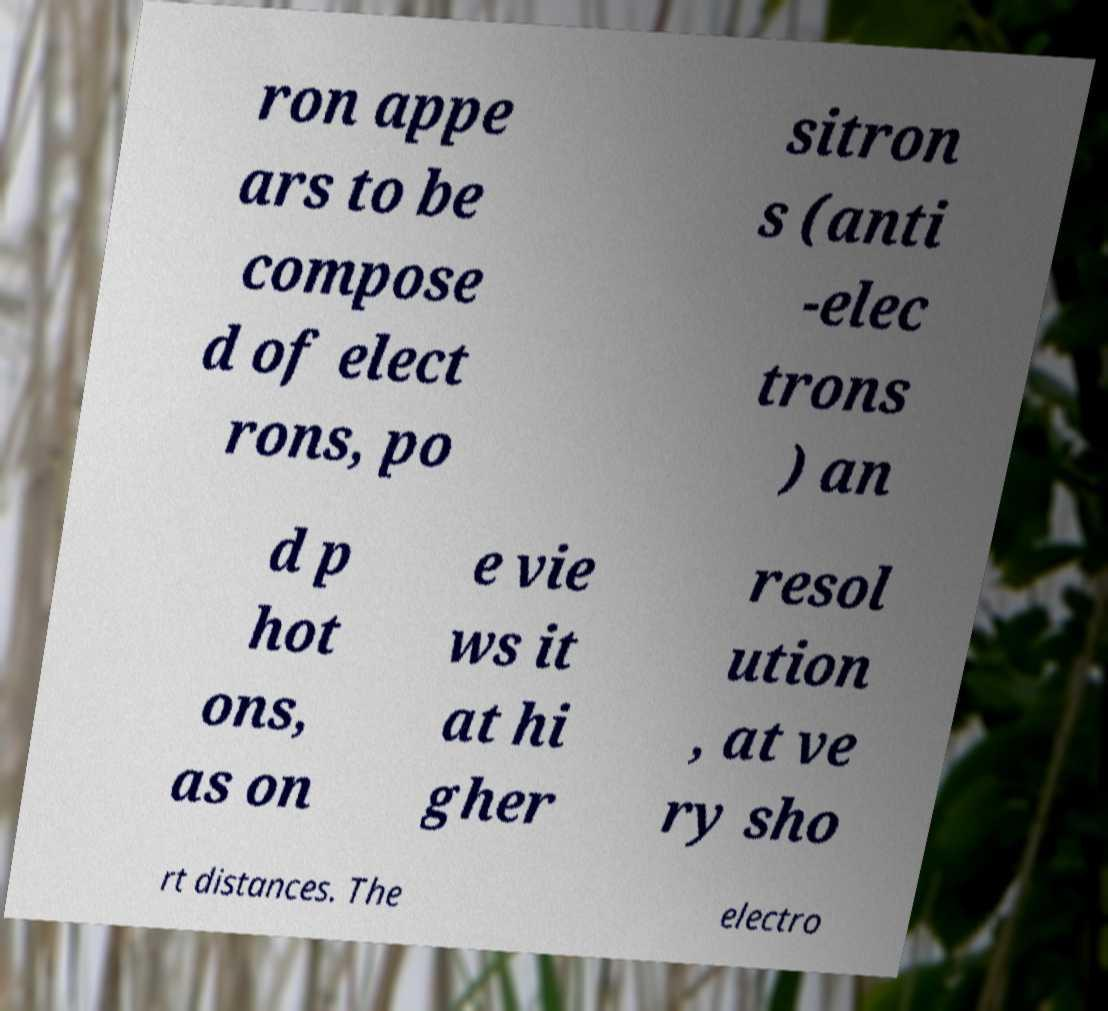What messages or text are displayed in this image? I need them in a readable, typed format. ron appe ars to be compose d of elect rons, po sitron s (anti -elec trons ) an d p hot ons, as on e vie ws it at hi gher resol ution , at ve ry sho rt distances. The electro 